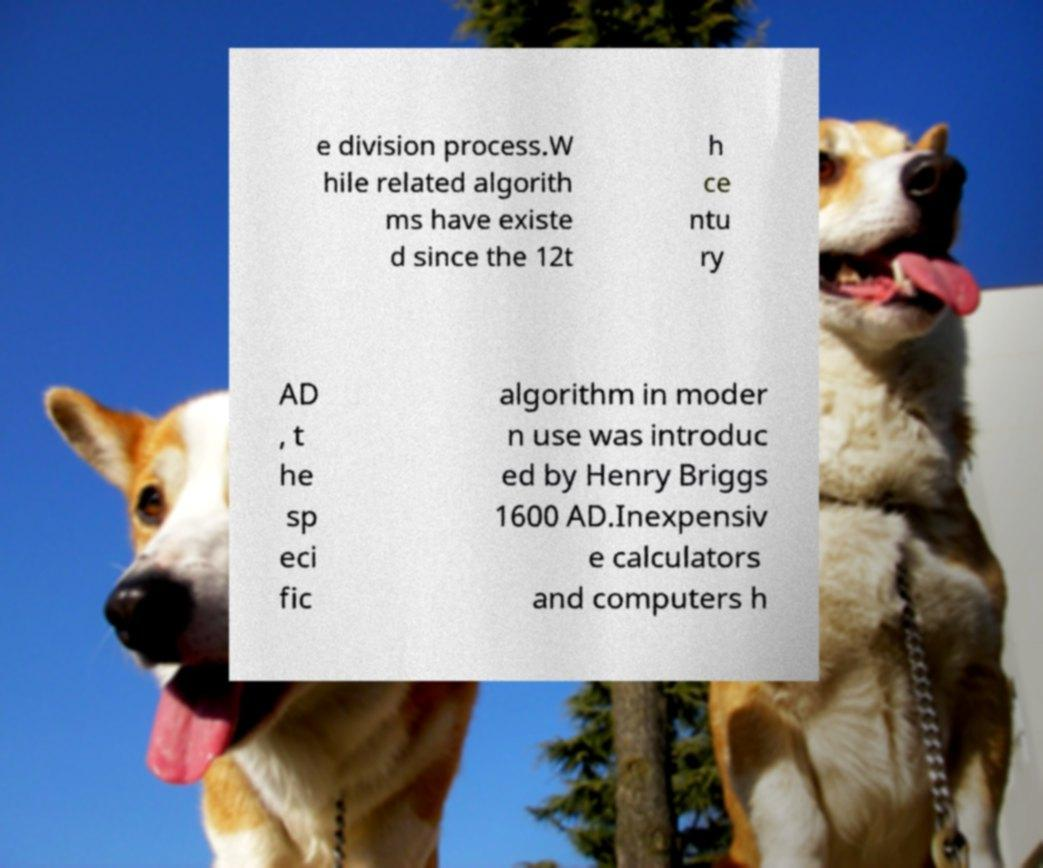What messages or text are displayed in this image? I need them in a readable, typed format. e division process.W hile related algorith ms have existe d since the 12t h ce ntu ry AD , t he sp eci fic algorithm in moder n use was introduc ed by Henry Briggs 1600 AD.Inexpensiv e calculators and computers h 